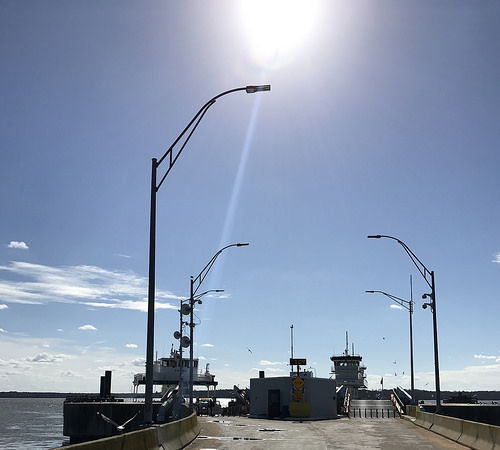<image>
Is there a sun above the ground? Yes. The sun is positioned above the ground in the vertical space, higher up in the scene. 